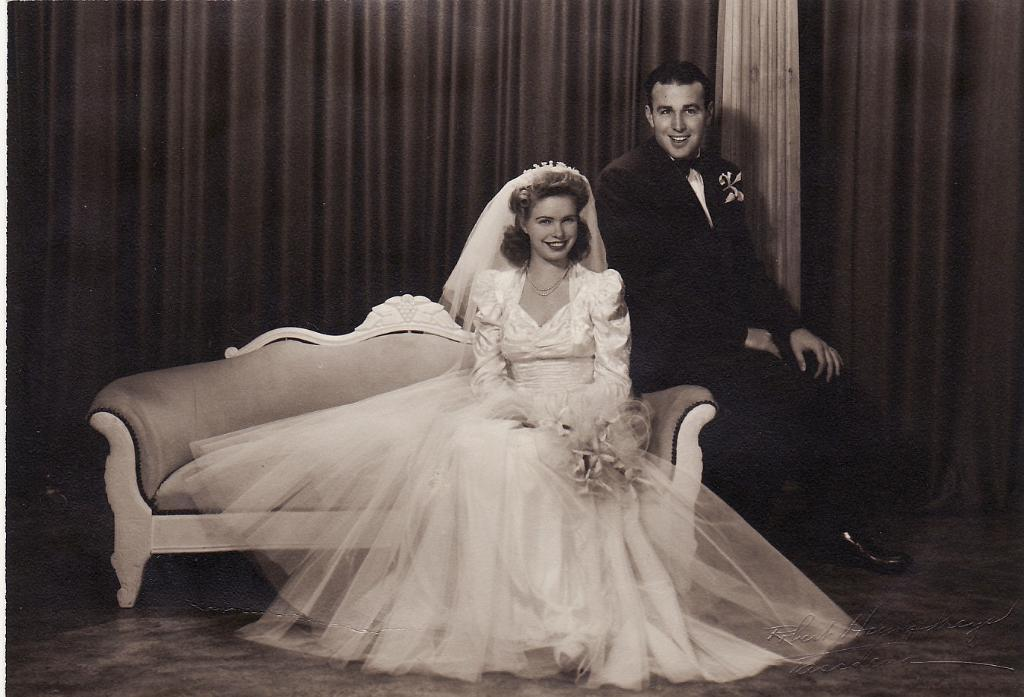What type of window treatment is visible in the image? There are curtains in the image. What are the two people in the image doing? They are sitting on a sofa in the image. What is the woman wearing in the image? The woman is wearing a white dress. What is the man wearing in the image? The man is wearing a black jacket. Can you see any snakes slithering on the wall in the image? There are no snakes or walls present in the image; it features two people sitting on a sofa with curtains in the background. 